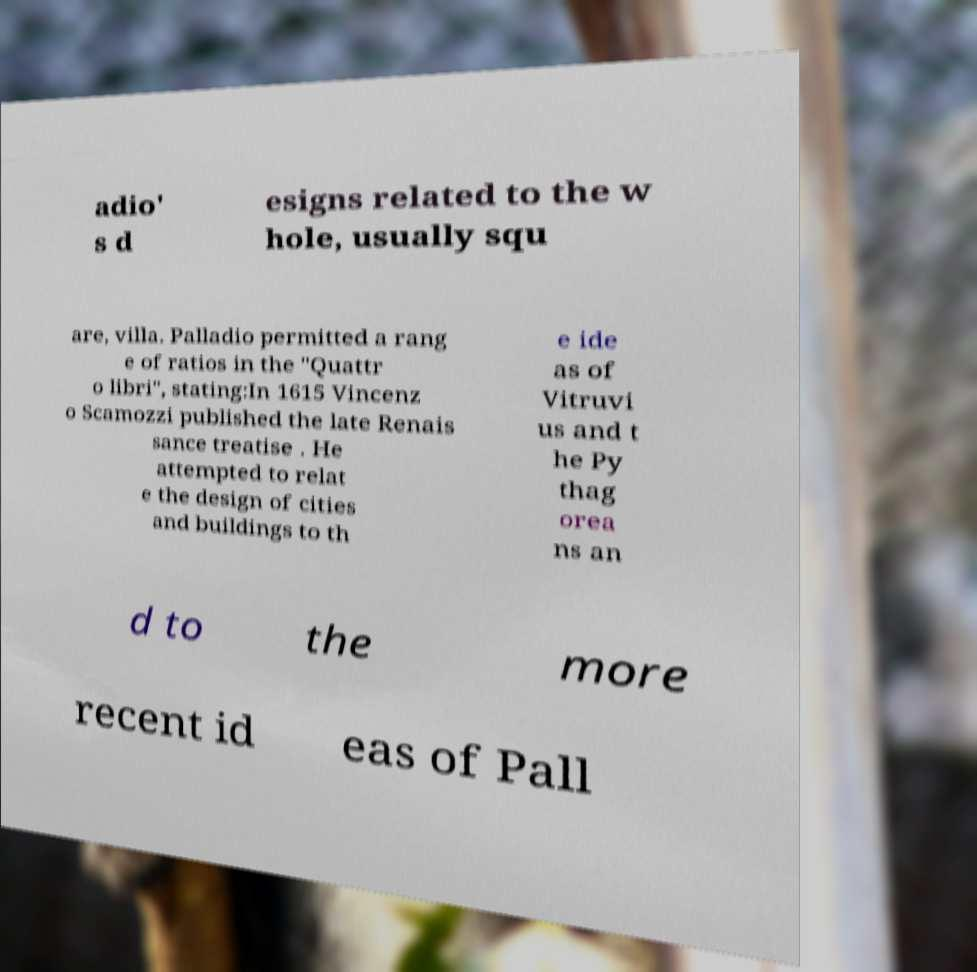There's text embedded in this image that I need extracted. Can you transcribe it verbatim? adio' s d esigns related to the w hole, usually squ are, villa. Palladio permitted a rang e of ratios in the "Quattr o libri", stating:In 1615 Vincenz o Scamozzi published the late Renais sance treatise . He attempted to relat e the design of cities and buildings to th e ide as of Vitruvi us and t he Py thag orea ns an d to the more recent id eas of Pall 